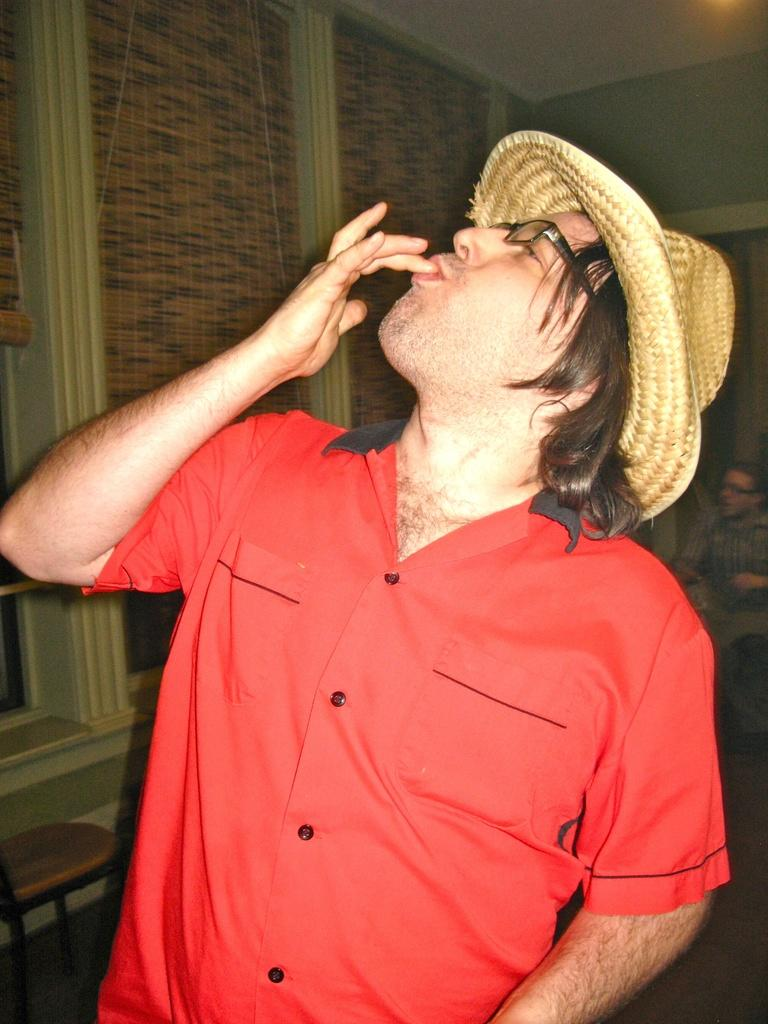What is the main subject of the image? There is a man standing in the image. Can you describe the man's attire? The man is wearing a hat. What can be seen in the background of the image? There is a wall and a window visible in the image. What type of furniture is present in the image? There is a chair in the image. What is the person sitting on in the image? The person sitting in the image is on a chair. What is the structure above the man in the image? There is a roof visible in the image. What type of cloth is being used for division in the image? There is no cloth being used for division in the image. What direction is the man facing in the image? The provided facts do not specify the direction the man is facing in the image. 